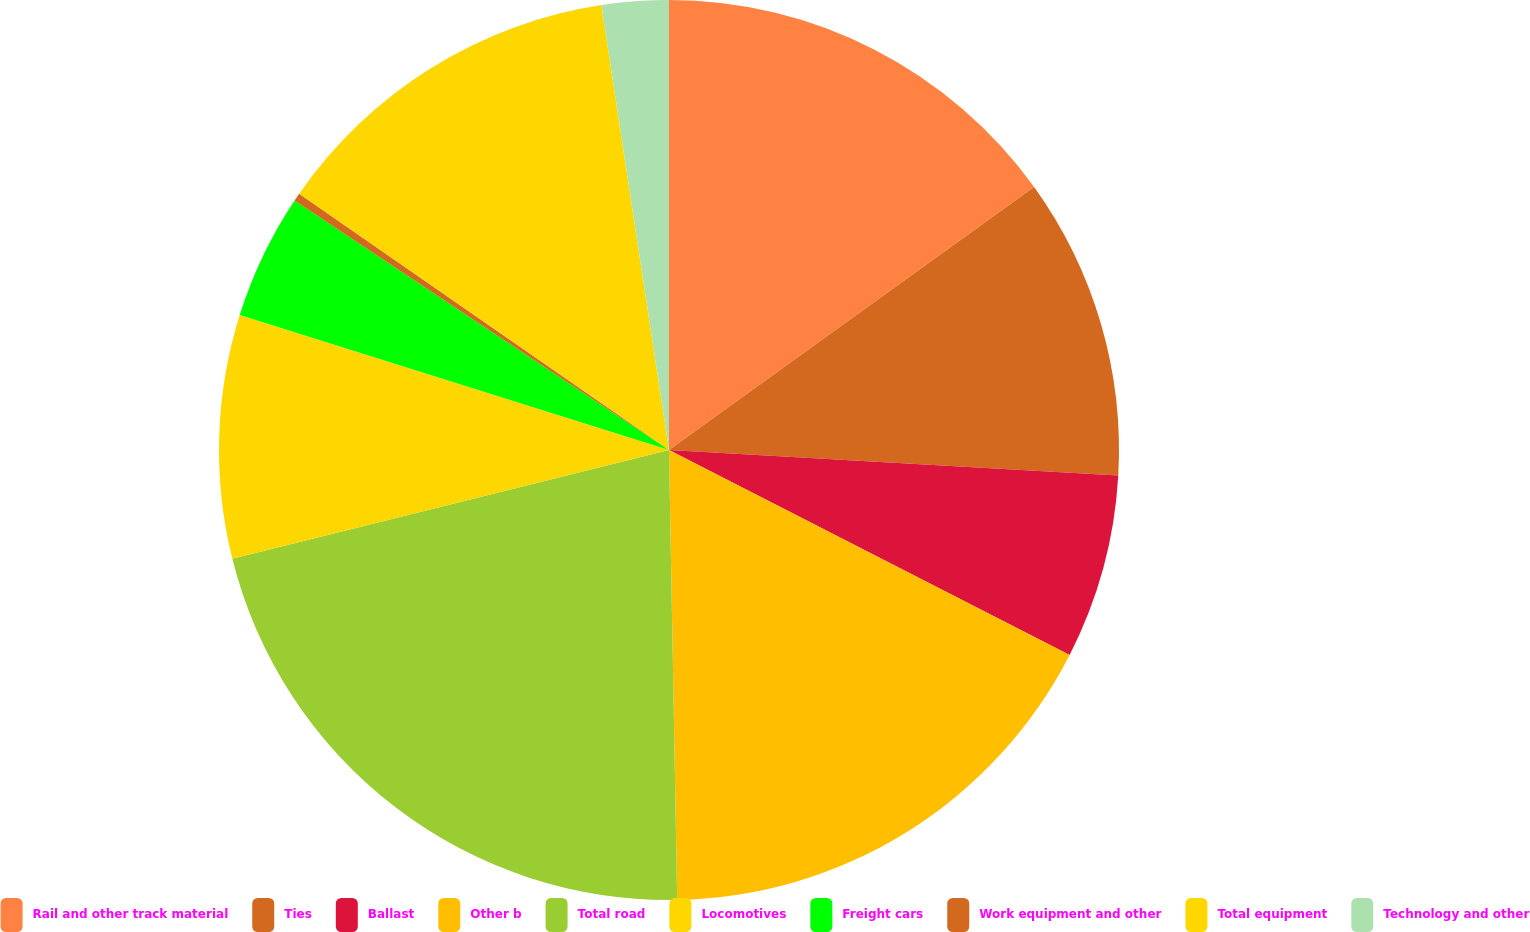Convert chart to OTSL. <chart><loc_0><loc_0><loc_500><loc_500><pie_chart><fcel>Rail and other track material<fcel>Ties<fcel>Ballast<fcel>Other b<fcel>Total road<fcel>Locomotives<fcel>Freight cars<fcel>Work equipment and other<fcel>Total equipment<fcel>Technology and other<nl><fcel>15.06%<fcel>10.84%<fcel>6.62%<fcel>17.18%<fcel>21.4%<fcel>8.73%<fcel>4.51%<fcel>0.29%<fcel>12.95%<fcel>2.4%<nl></chart> 